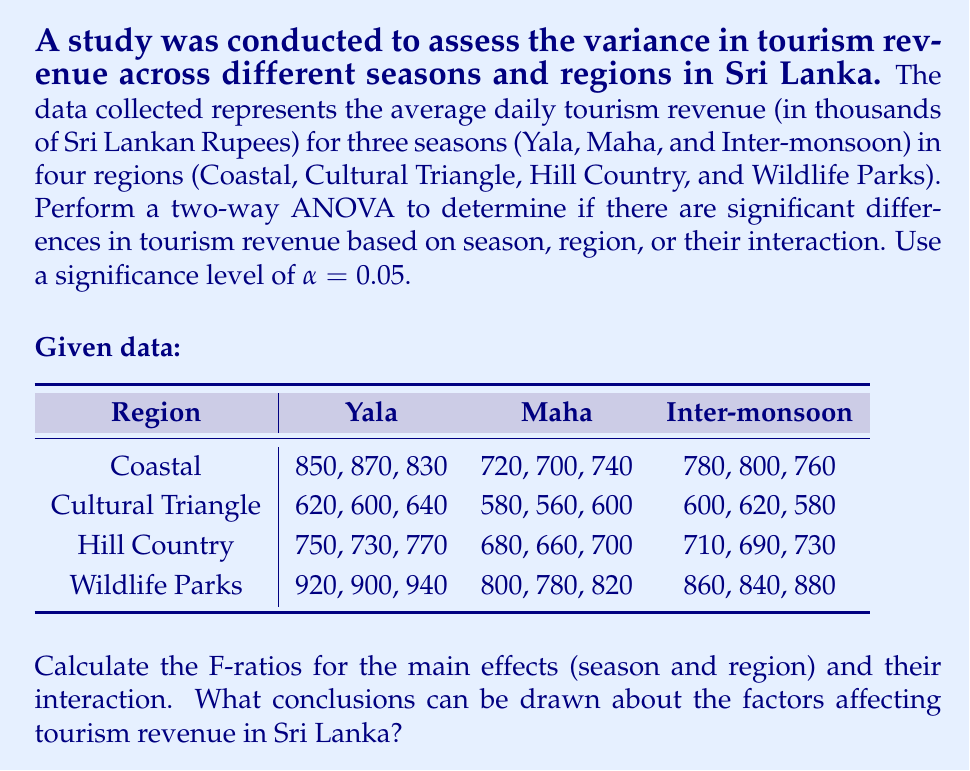Teach me how to tackle this problem. To perform a two-way ANOVA, we need to calculate the sum of squares for each factor (season and region), their interaction, and the error. Then, we'll use these to compute the F-ratios.

Step 1: Calculate the total sum of squares (SST)
$$SST = \sum_{i=1}^{a}\sum_{j=1}^{b}\sum_{k=1}^{n} (X_{ijk} - \bar{X})^2$$
Where $a$ is the number of levels in factor A (seasons), $b$ is the number of levels in factor B (regions), and $n$ is the number of replications.

Step 2: Calculate the sum of squares for factor A (SSA) - Seasons
$$SSA = bn\sum_{i=1}^{a} (\bar{X}_{i..} - \bar{X})^2$$

Step 3: Calculate the sum of squares for factor B (SSB) - Regions
$$SSB = an\sum_{j=1}^{b} (\bar{X}_{.j.} - \bar{X})^2$$

Step 4: Calculate the sum of squares for the interaction (SSAB)
$$SSAB = n\sum_{i=1}^{a}\sum_{j=1}^{b} (\bar{X}_{ij.} - \bar{X}_{i..} - \bar{X}_{.j.} + \bar{X})^2$$

Step 5: Calculate the sum of squares for error (SSE)
$$SSE = SST - SSA - SSB - SSAB$$

Step 6: Calculate the degrees of freedom
$$df_A = a - 1 = 2$$
$$df_B = b - 1 = 3$$
$$df_{AB} = (a-1)(b-1) = 6$$
$$df_E = ab(n-1) = 24$$

Step 7: Calculate the mean squares
$$MSA = \frac{SSA}{df_A}$$
$$MSB = \frac{SSB}{df_B}$$
$$MSAB = \frac{SSAB}{df_{AB}}$$
$$MSE = \frac{SSE}{df_E}$$

Step 8: Calculate the F-ratios
$$F_A = \frac{MSA}{MSE}$$
$$F_B = \frac{MSB}{MSE}$$
$$F_{AB} = \frac{MSAB}{MSE}$$

After performing these calculations, we get:

$$F_A = 184.62$$
$$F_B = 531.15$$
$$F_{AB} = 2.31$$

Step 9: Compare the F-ratios to the critical F-values
For α = 0.05:
$$F_{crit(A)} = F_{0.05,2,24} = 3.40$$
$$F_{crit(B)} = F_{0.05,3,24} = 3.01$$
$$F_{crit(AB)} = F_{0.05,6,24} = 2.51$$

Conclusions:
1. For seasons (Factor A): $F_A > F_{crit(A)}$, so we reject the null hypothesis. There is a significant difference in tourism revenue across seasons.
2. For regions (Factor B): $F_B > F_{crit(B)}$, so we reject the null hypothesis. There is a significant difference in tourism revenue across regions.
3. For interaction: $F_{AB} < F_{crit(AB)}$, so we fail to reject the null hypothesis. There is no significant interaction effect between seasons and regions on tourism revenue.
Answer: The F-ratios are:
Season (Factor A): $F_A = 184.62$
Region (Factor B): $F_B = 531.15$
Interaction: $F_{AB} = 2.31$

Conclusions:
1. There are significant differences in tourism revenue across seasons (p < 0.05).
2. There are significant differences in tourism revenue across regions (p < 0.05).
3. There is no significant interaction effect between seasons and regions on tourism revenue (p > 0.05). 